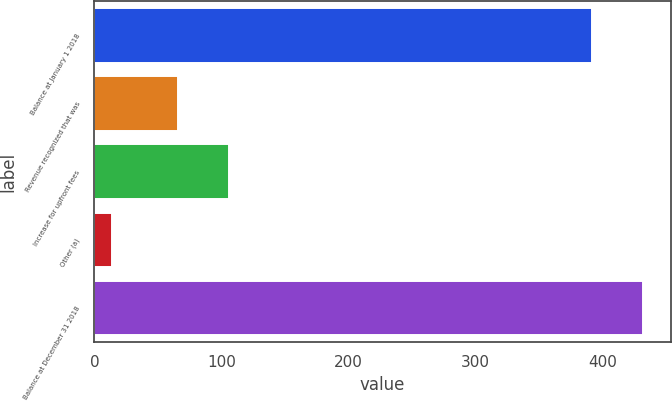<chart> <loc_0><loc_0><loc_500><loc_500><bar_chart><fcel>Balance at January 1 2018<fcel>Revenue recognized that was<fcel>Increase for upfront fees<fcel>Other (a)<fcel>Balance at December 31 2018<nl><fcel>392<fcel>66<fcel>106<fcel>14<fcel>432<nl></chart> 